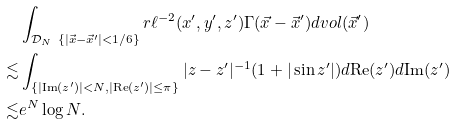Convert formula to latex. <formula><loc_0><loc_0><loc_500><loc_500>& \int _ { \mathcal { D } _ { N } \ \{ | \vec { x } - \vec { x } ^ { \prime } | < 1 / 6 \} } r \ell ^ { - 2 } ( x ^ { \prime } , y ^ { \prime } , z ^ { \prime } ) \Gamma ( \vec { x } - \vec { x } ^ { \prime } ) d v o l ( \vec { x } ^ { \prime } ) \\ \lesssim & \int _ { \{ | \text {Im} ( z ^ { \prime } ) | < N , | \text {Re} ( z ^ { \prime } ) | \leq \pi \} } | z - z ^ { \prime } | ^ { - 1 } ( 1 + | \sin z ^ { \prime } | ) d \text {Re} ( z ^ { \prime } ) d \text {Im} ( z ^ { \prime } ) \\ \lesssim & e ^ { N } \log N .</formula> 